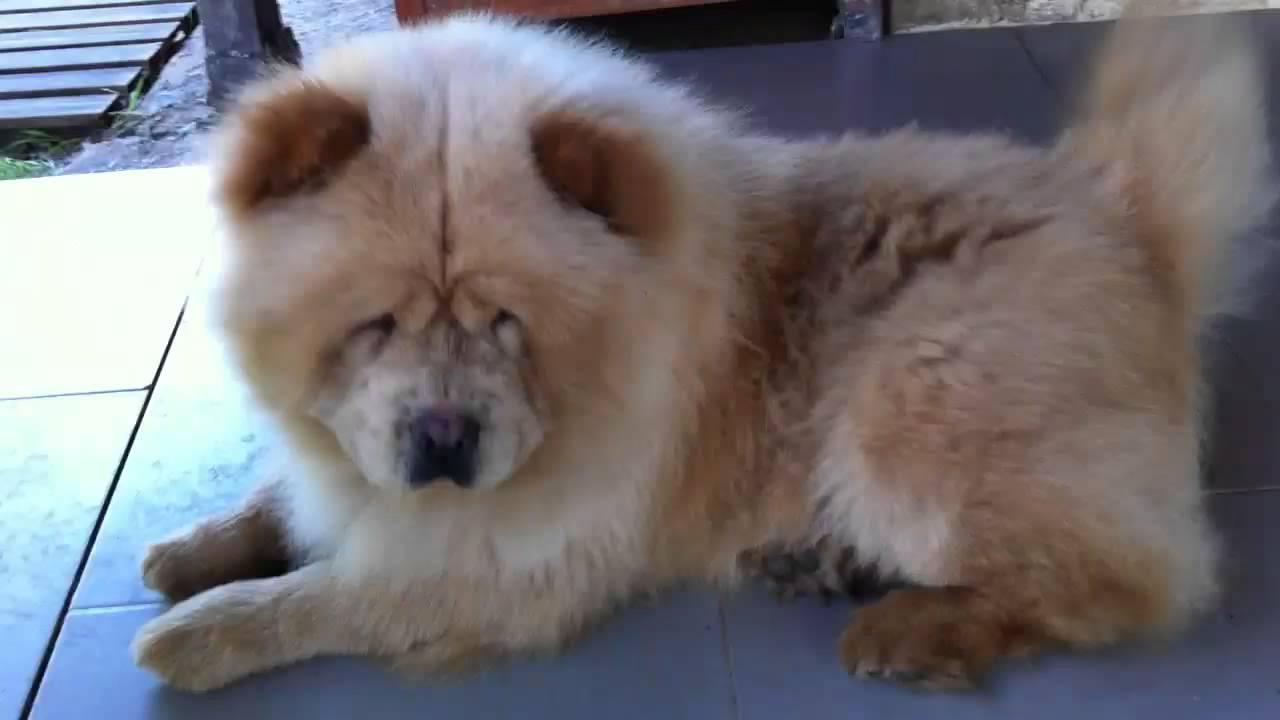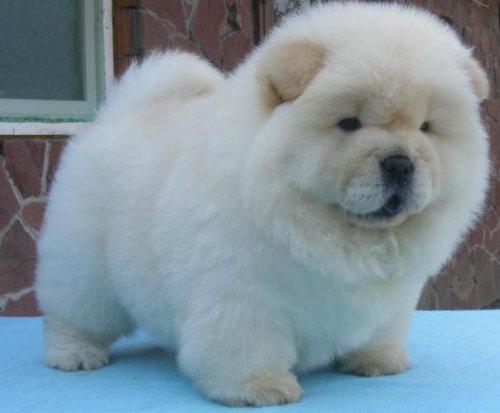The first image is the image on the left, the second image is the image on the right. Evaluate the accuracy of this statement regarding the images: "The combined images include two fluffy puppies with similar poses, expressions and colors.". Is it true? Answer yes or no. No. The first image is the image on the left, the second image is the image on the right. Considering the images on both sides, is "A single dog is standing on all fours in the image on the right." valid? Answer yes or no. Yes. 